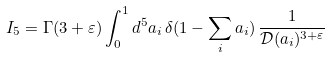Convert formula to latex. <formula><loc_0><loc_0><loc_500><loc_500>I _ { 5 } = \Gamma ( 3 + \varepsilon ) \int _ { 0 } ^ { 1 } d ^ { 5 } a _ { i } \, \delta ( 1 - \sum _ { i } a _ { i } ) \, \frac { 1 } { { \mathcal { D } } ( a _ { i } ) ^ { 3 + \varepsilon } }</formula> 